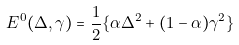Convert formula to latex. <formula><loc_0><loc_0><loc_500><loc_500>E ^ { 0 } ( \Delta , \gamma ) = \frac { 1 } { 2 } \{ \alpha \Delta ^ { 2 } + ( 1 - \alpha ) \gamma ^ { 2 } \}</formula> 